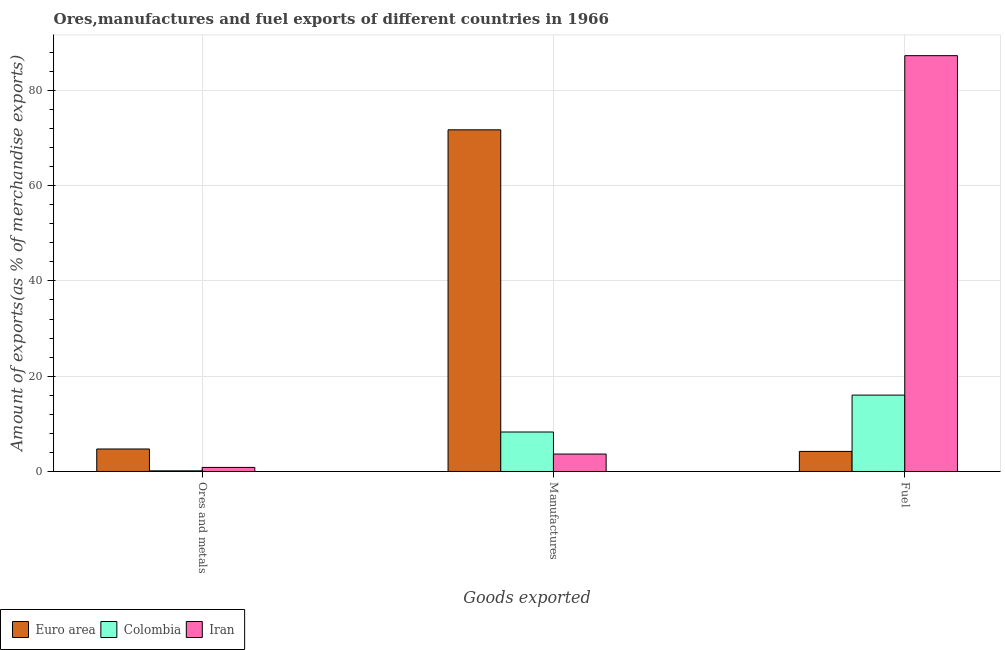Are the number of bars per tick equal to the number of legend labels?
Your response must be concise. Yes. Are the number of bars on each tick of the X-axis equal?
Provide a succinct answer. Yes. What is the label of the 1st group of bars from the left?
Ensure brevity in your answer.  Ores and metals. What is the percentage of ores and metals exports in Colombia?
Offer a very short reply. 0.14. Across all countries, what is the maximum percentage of ores and metals exports?
Your response must be concise. 4.72. Across all countries, what is the minimum percentage of manufactures exports?
Your response must be concise. 3.66. In which country was the percentage of manufactures exports maximum?
Offer a terse response. Euro area. What is the total percentage of manufactures exports in the graph?
Your response must be concise. 83.65. What is the difference between the percentage of fuel exports in Euro area and that in Colombia?
Your answer should be compact. -11.82. What is the difference between the percentage of fuel exports in Euro area and the percentage of ores and metals exports in Colombia?
Keep it short and to the point. 4.07. What is the average percentage of manufactures exports per country?
Give a very brief answer. 27.88. What is the difference between the percentage of ores and metals exports and percentage of fuel exports in Colombia?
Your answer should be compact. -15.89. What is the ratio of the percentage of ores and metals exports in Euro area to that in Colombia?
Your response must be concise. 33.79. Is the percentage of fuel exports in Colombia less than that in Euro area?
Keep it short and to the point. No. Is the difference between the percentage of fuel exports in Euro area and Iran greater than the difference between the percentage of manufactures exports in Euro area and Iran?
Your response must be concise. No. What is the difference between the highest and the second highest percentage of manufactures exports?
Provide a short and direct response. 63.42. What is the difference between the highest and the lowest percentage of ores and metals exports?
Ensure brevity in your answer.  4.58. Is the sum of the percentage of manufactures exports in Colombia and Euro area greater than the maximum percentage of fuel exports across all countries?
Make the answer very short. No. What does the 3rd bar from the left in Manufactures represents?
Provide a short and direct response. Iran. What does the 1st bar from the right in Manufactures represents?
Your answer should be compact. Iran. How many bars are there?
Ensure brevity in your answer.  9. Are all the bars in the graph horizontal?
Ensure brevity in your answer.  No. How many countries are there in the graph?
Make the answer very short. 3. What is the difference between two consecutive major ticks on the Y-axis?
Offer a very short reply. 20. Are the values on the major ticks of Y-axis written in scientific E-notation?
Offer a very short reply. No. Does the graph contain any zero values?
Your answer should be very brief. No. Does the graph contain grids?
Provide a succinct answer. Yes. How are the legend labels stacked?
Provide a short and direct response. Horizontal. What is the title of the graph?
Offer a terse response. Ores,manufactures and fuel exports of different countries in 1966. Does "Tunisia" appear as one of the legend labels in the graph?
Ensure brevity in your answer.  No. What is the label or title of the X-axis?
Your answer should be very brief. Goods exported. What is the label or title of the Y-axis?
Make the answer very short. Amount of exports(as % of merchandise exports). What is the Amount of exports(as % of merchandise exports) of Euro area in Ores and metals?
Your response must be concise. 4.72. What is the Amount of exports(as % of merchandise exports) in Colombia in Ores and metals?
Give a very brief answer. 0.14. What is the Amount of exports(as % of merchandise exports) in Iran in Ores and metals?
Give a very brief answer. 0.86. What is the Amount of exports(as % of merchandise exports) in Euro area in Manufactures?
Provide a succinct answer. 71.71. What is the Amount of exports(as % of merchandise exports) of Colombia in Manufactures?
Your response must be concise. 8.29. What is the Amount of exports(as % of merchandise exports) in Iran in Manufactures?
Provide a short and direct response. 3.66. What is the Amount of exports(as % of merchandise exports) of Euro area in Fuel?
Give a very brief answer. 4.21. What is the Amount of exports(as % of merchandise exports) of Colombia in Fuel?
Provide a short and direct response. 16.03. What is the Amount of exports(as % of merchandise exports) in Iran in Fuel?
Provide a succinct answer. 87.27. Across all Goods exported, what is the maximum Amount of exports(as % of merchandise exports) in Euro area?
Provide a succinct answer. 71.71. Across all Goods exported, what is the maximum Amount of exports(as % of merchandise exports) of Colombia?
Provide a succinct answer. 16.03. Across all Goods exported, what is the maximum Amount of exports(as % of merchandise exports) in Iran?
Your answer should be very brief. 87.27. Across all Goods exported, what is the minimum Amount of exports(as % of merchandise exports) in Euro area?
Your answer should be compact. 4.21. Across all Goods exported, what is the minimum Amount of exports(as % of merchandise exports) of Colombia?
Make the answer very short. 0.14. Across all Goods exported, what is the minimum Amount of exports(as % of merchandise exports) in Iran?
Provide a succinct answer. 0.86. What is the total Amount of exports(as % of merchandise exports) in Euro area in the graph?
Offer a terse response. 80.64. What is the total Amount of exports(as % of merchandise exports) in Colombia in the graph?
Give a very brief answer. 24.46. What is the total Amount of exports(as % of merchandise exports) of Iran in the graph?
Offer a very short reply. 91.78. What is the difference between the Amount of exports(as % of merchandise exports) of Euro area in Ores and metals and that in Manufactures?
Offer a very short reply. -66.99. What is the difference between the Amount of exports(as % of merchandise exports) of Colombia in Ores and metals and that in Manufactures?
Offer a very short reply. -8.15. What is the difference between the Amount of exports(as % of merchandise exports) in Iran in Ores and metals and that in Manufactures?
Offer a very short reply. -2.8. What is the difference between the Amount of exports(as % of merchandise exports) of Euro area in Ores and metals and that in Fuel?
Give a very brief answer. 0.51. What is the difference between the Amount of exports(as % of merchandise exports) in Colombia in Ores and metals and that in Fuel?
Offer a terse response. -15.89. What is the difference between the Amount of exports(as % of merchandise exports) in Iran in Ores and metals and that in Fuel?
Your response must be concise. -86.42. What is the difference between the Amount of exports(as % of merchandise exports) of Euro area in Manufactures and that in Fuel?
Your answer should be compact. 67.49. What is the difference between the Amount of exports(as % of merchandise exports) in Colombia in Manufactures and that in Fuel?
Keep it short and to the point. -7.75. What is the difference between the Amount of exports(as % of merchandise exports) of Iran in Manufactures and that in Fuel?
Your answer should be very brief. -83.61. What is the difference between the Amount of exports(as % of merchandise exports) of Euro area in Ores and metals and the Amount of exports(as % of merchandise exports) of Colombia in Manufactures?
Your response must be concise. -3.57. What is the difference between the Amount of exports(as % of merchandise exports) in Euro area in Ores and metals and the Amount of exports(as % of merchandise exports) in Iran in Manufactures?
Your answer should be very brief. 1.06. What is the difference between the Amount of exports(as % of merchandise exports) of Colombia in Ores and metals and the Amount of exports(as % of merchandise exports) of Iran in Manufactures?
Keep it short and to the point. -3.52. What is the difference between the Amount of exports(as % of merchandise exports) of Euro area in Ores and metals and the Amount of exports(as % of merchandise exports) of Colombia in Fuel?
Provide a short and direct response. -11.31. What is the difference between the Amount of exports(as % of merchandise exports) of Euro area in Ores and metals and the Amount of exports(as % of merchandise exports) of Iran in Fuel?
Provide a short and direct response. -82.55. What is the difference between the Amount of exports(as % of merchandise exports) of Colombia in Ores and metals and the Amount of exports(as % of merchandise exports) of Iran in Fuel?
Make the answer very short. -87.13. What is the difference between the Amount of exports(as % of merchandise exports) in Euro area in Manufactures and the Amount of exports(as % of merchandise exports) in Colombia in Fuel?
Make the answer very short. 55.67. What is the difference between the Amount of exports(as % of merchandise exports) of Euro area in Manufactures and the Amount of exports(as % of merchandise exports) of Iran in Fuel?
Ensure brevity in your answer.  -15.56. What is the difference between the Amount of exports(as % of merchandise exports) of Colombia in Manufactures and the Amount of exports(as % of merchandise exports) of Iran in Fuel?
Ensure brevity in your answer.  -78.98. What is the average Amount of exports(as % of merchandise exports) of Euro area per Goods exported?
Make the answer very short. 26.88. What is the average Amount of exports(as % of merchandise exports) of Colombia per Goods exported?
Keep it short and to the point. 8.15. What is the average Amount of exports(as % of merchandise exports) in Iran per Goods exported?
Provide a short and direct response. 30.59. What is the difference between the Amount of exports(as % of merchandise exports) of Euro area and Amount of exports(as % of merchandise exports) of Colombia in Ores and metals?
Offer a very short reply. 4.58. What is the difference between the Amount of exports(as % of merchandise exports) in Euro area and Amount of exports(as % of merchandise exports) in Iran in Ores and metals?
Make the answer very short. 3.87. What is the difference between the Amount of exports(as % of merchandise exports) in Colombia and Amount of exports(as % of merchandise exports) in Iran in Ores and metals?
Offer a terse response. -0.72. What is the difference between the Amount of exports(as % of merchandise exports) in Euro area and Amount of exports(as % of merchandise exports) in Colombia in Manufactures?
Give a very brief answer. 63.42. What is the difference between the Amount of exports(as % of merchandise exports) in Euro area and Amount of exports(as % of merchandise exports) in Iran in Manufactures?
Your answer should be compact. 68.05. What is the difference between the Amount of exports(as % of merchandise exports) in Colombia and Amount of exports(as % of merchandise exports) in Iran in Manufactures?
Make the answer very short. 4.63. What is the difference between the Amount of exports(as % of merchandise exports) in Euro area and Amount of exports(as % of merchandise exports) in Colombia in Fuel?
Keep it short and to the point. -11.82. What is the difference between the Amount of exports(as % of merchandise exports) in Euro area and Amount of exports(as % of merchandise exports) in Iran in Fuel?
Provide a short and direct response. -83.06. What is the difference between the Amount of exports(as % of merchandise exports) in Colombia and Amount of exports(as % of merchandise exports) in Iran in Fuel?
Keep it short and to the point. -71.24. What is the ratio of the Amount of exports(as % of merchandise exports) in Euro area in Ores and metals to that in Manufactures?
Keep it short and to the point. 0.07. What is the ratio of the Amount of exports(as % of merchandise exports) in Colombia in Ores and metals to that in Manufactures?
Ensure brevity in your answer.  0.02. What is the ratio of the Amount of exports(as % of merchandise exports) of Iran in Ores and metals to that in Manufactures?
Provide a succinct answer. 0.23. What is the ratio of the Amount of exports(as % of merchandise exports) in Euro area in Ores and metals to that in Fuel?
Your answer should be compact. 1.12. What is the ratio of the Amount of exports(as % of merchandise exports) in Colombia in Ores and metals to that in Fuel?
Keep it short and to the point. 0.01. What is the ratio of the Amount of exports(as % of merchandise exports) in Iran in Ores and metals to that in Fuel?
Keep it short and to the point. 0.01. What is the ratio of the Amount of exports(as % of merchandise exports) in Euro area in Manufactures to that in Fuel?
Offer a terse response. 17.02. What is the ratio of the Amount of exports(as % of merchandise exports) of Colombia in Manufactures to that in Fuel?
Provide a succinct answer. 0.52. What is the ratio of the Amount of exports(as % of merchandise exports) of Iran in Manufactures to that in Fuel?
Your answer should be compact. 0.04. What is the difference between the highest and the second highest Amount of exports(as % of merchandise exports) of Euro area?
Keep it short and to the point. 66.99. What is the difference between the highest and the second highest Amount of exports(as % of merchandise exports) in Colombia?
Offer a very short reply. 7.75. What is the difference between the highest and the second highest Amount of exports(as % of merchandise exports) of Iran?
Your answer should be compact. 83.61. What is the difference between the highest and the lowest Amount of exports(as % of merchandise exports) in Euro area?
Offer a very short reply. 67.49. What is the difference between the highest and the lowest Amount of exports(as % of merchandise exports) in Colombia?
Give a very brief answer. 15.89. What is the difference between the highest and the lowest Amount of exports(as % of merchandise exports) in Iran?
Ensure brevity in your answer.  86.42. 